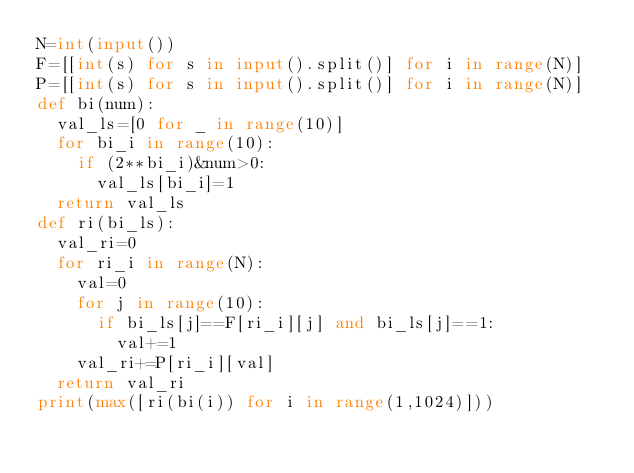Convert code to text. <code><loc_0><loc_0><loc_500><loc_500><_Python_>N=int(input())
F=[[int(s) for s in input().split()] for i in range(N)]
P=[[int(s) for s in input().split()] for i in range(N)]
def bi(num):
  val_ls=[0 for _ in range(10)]
  for bi_i in range(10):
    if (2**bi_i)&num>0:
      val_ls[bi_i]=1
  return val_ls
def ri(bi_ls):
  val_ri=0
  for ri_i in range(N):
    val=0
    for j in range(10):
      if bi_ls[j]==F[ri_i][j] and bi_ls[j]==1:
        val+=1
    val_ri+=P[ri_i][val]
  return val_ri
print(max([ri(bi(i)) for i in range(1,1024)]))
      
  </code> 